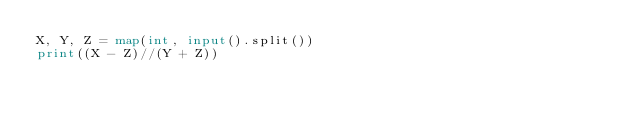Convert code to text. <code><loc_0><loc_0><loc_500><loc_500><_Python_>X, Y, Z = map(int, input().split())
print((X - Z)//(Y + Z))</code> 